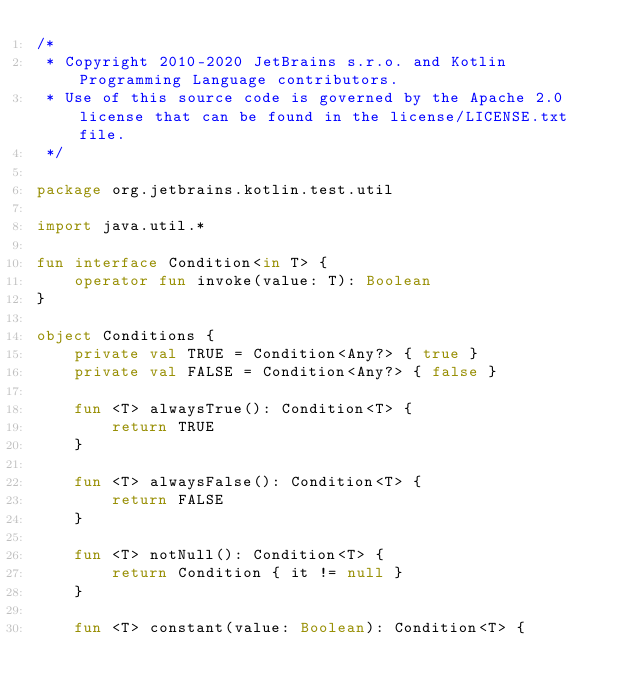Convert code to text. <code><loc_0><loc_0><loc_500><loc_500><_Kotlin_>/*
 * Copyright 2010-2020 JetBrains s.r.o. and Kotlin Programming Language contributors.
 * Use of this source code is governed by the Apache 2.0 license that can be found in the license/LICENSE.txt file.
 */

package org.jetbrains.kotlin.test.util

import java.util.*

fun interface Condition<in T> {
    operator fun invoke(value: T): Boolean
}

object Conditions {
    private val TRUE = Condition<Any?> { true }
    private val FALSE = Condition<Any?> { false }

    fun <T> alwaysTrue(): Condition<T> {
        return TRUE
    }

    fun <T> alwaysFalse(): Condition<T> {
        return FALSE
    }

    fun <T> notNull(): Condition<T> {
        return Condition { it != null }
    }

    fun <T> constant(value: Boolean): Condition<T> {</code> 